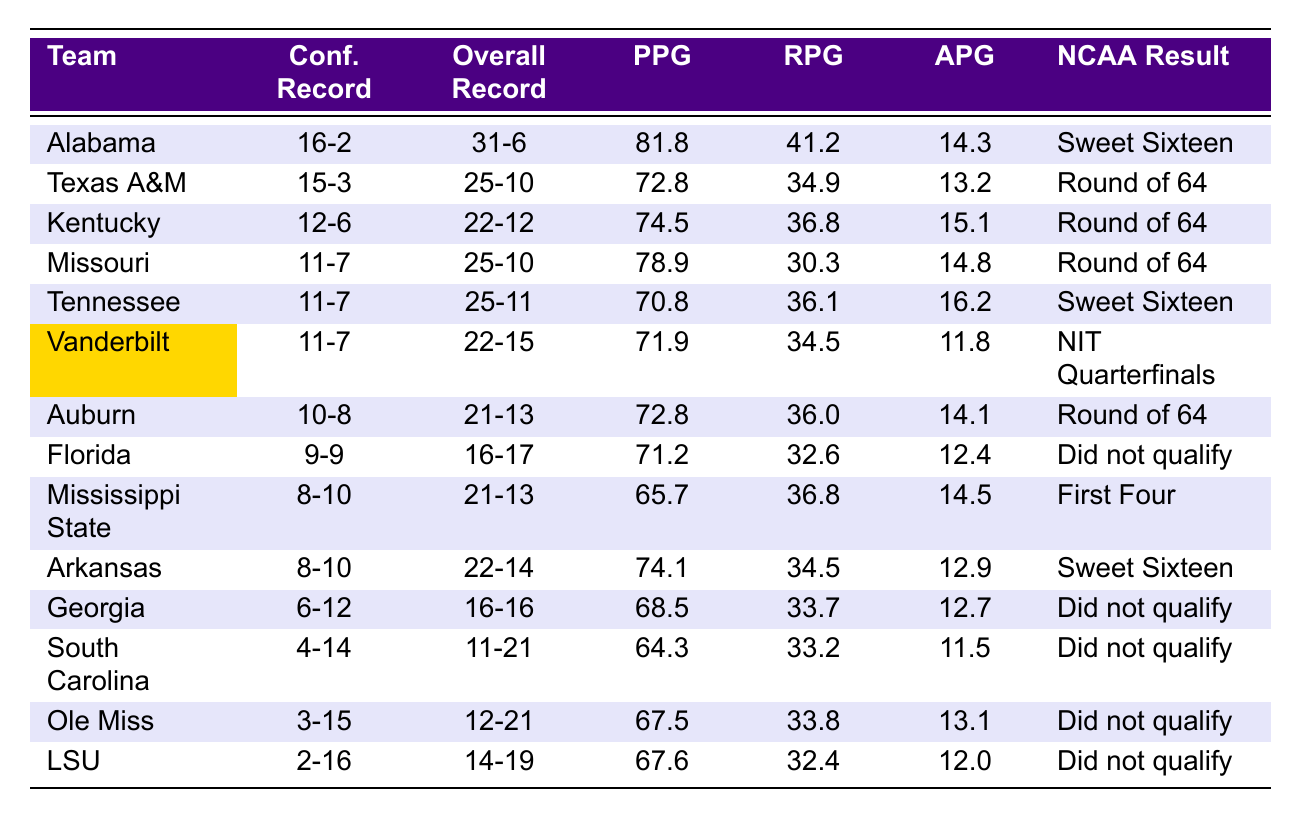What was Vanderbilt's overall record in the 2022-2023 season? Vanderbilt's overall record is listed in the table as 22-15.
Answer: 22-15 Which team had the highest points per game (PPG) in the SEC during the 2022-2023 season? The team with the highest PPG is Alabama at 81.8.
Answer: Alabama Did Ole Miss qualify for the NCAA tournament in the 2022-2023 season? According to the table, Ole Miss did not qualify for the NCAA tournament, as it states "Did not qualify."
Answer: No What is the difference in total wins between Alabama and Kentucky? Alabama has an overall record of 31-6, equating to 31 wins, while Kentucky has 22 wins (22-12). The difference is 31 - 22 = 9.
Answer: 9 Which teams reached the Sweet Sixteen in the NCAA tournament? The teams that reached the Sweet Sixteen were Alabama and Tennessee, as indicated in the NCAA Tournament Result column.
Answer: Alabama, Tennessee How many teams in the table had a conference record of 11-7? There are three teams with a conference record of 11-7: Vanderbilt, Tennessee, and Missouri.
Answer: 3 What is the average rebounds per game (RPG) for teams that did not qualify for the NCAA tournament? The teams that did not qualify are Florida, Georgia, South Carolina, Ole Miss, and LSU. Their RPGs are 32.6, 33.7, 33.2, 33.8, and 32.4 respectively. The average is (32.6 + 33.7 + 33.2 + 33.8 + 32.4) / 5 = 33.14.
Answer: 33.14 Which SEC team had the lowest assists per game (APG)? The table shows that South Carolina had the lowest assists per game with 11.5.
Answer: South Carolina Calculate the total number of wins from the teams that reached the Round of 64. The teams in the Round of 64 are Texas A&M, Kentucky, Missouri, Auburn, Mississippi State, and Arkansas. Their total wins are 25 (Texas A&M) + 22 (Kentucky) + 25 (Missouri) + 21 (Auburn) + 21 (Mississippi State) + 22 (Arkansas) = 136 wins.
Answer: 136 What percentage of teams had a conference record of .500 or better? There are 14 teams in total, with 7 having a conference record of .500 or better (Alabama, Texas A&M, Kentucky, Missouri, Tennessee, Vanderbilt, and Auburn). The percentage is (7/14) * 100 = 50%.
Answer: 50% 